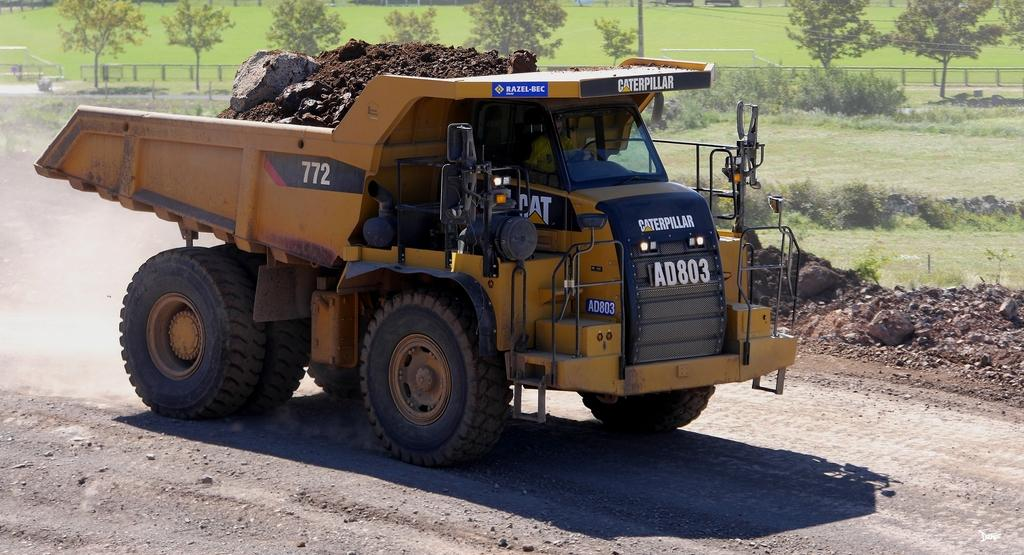What type of vehicle is in the image? There is a lorry in the image. What color is the lorry? The lorry is yellow. What is the lorry doing in the image? The lorry is moving on the road. What can be seen in the background of the image? There are trees and plants on the ground in the background of the image. How does the lorry adjust its temper while driving on the road? The lorry does not have a temper, as it is an inanimate object. It is simply moving on the road. 